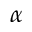Convert formula to latex. <formula><loc_0><loc_0><loc_500><loc_500>\alpha</formula> 